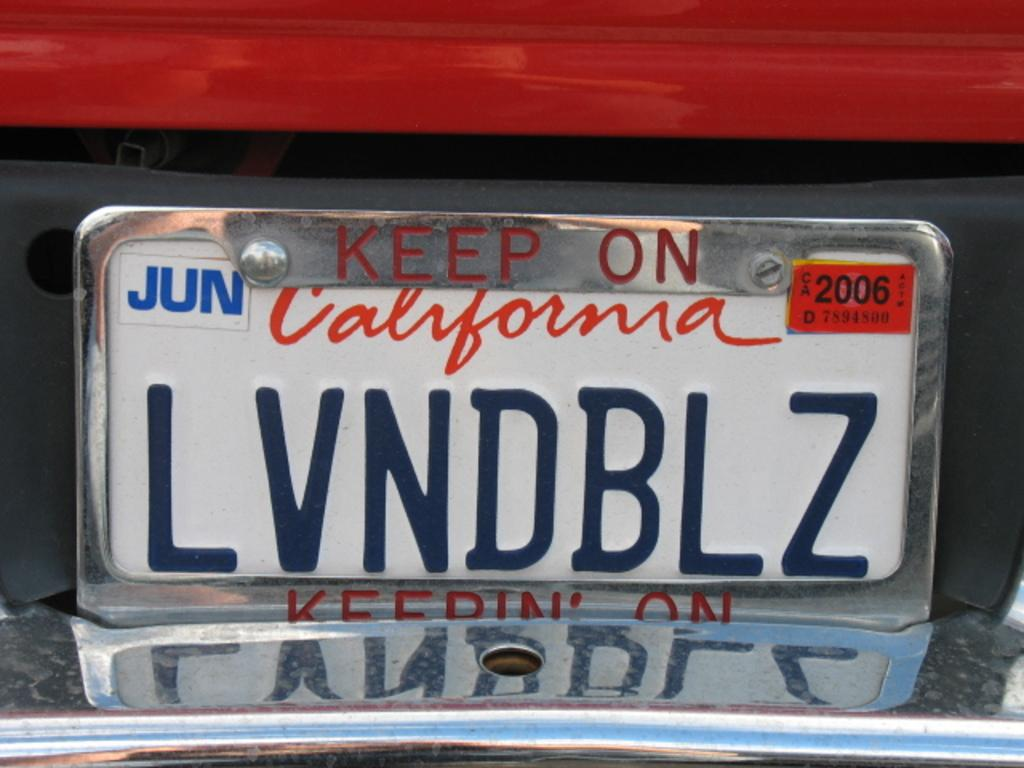<image>
Summarize the visual content of the image. A red and silver car with a number plate from California. 